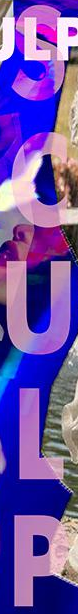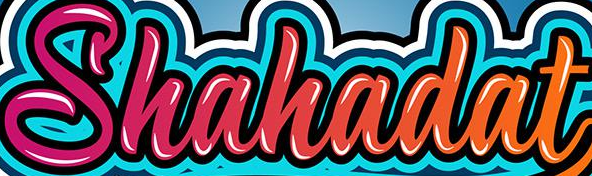Identify the words shown in these images in order, separated by a semicolon. SCULP; Shahadat 